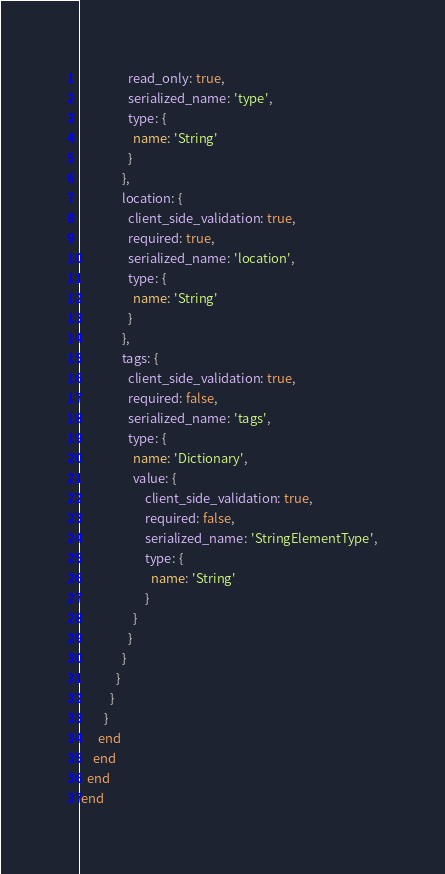Convert code to text. <code><loc_0><loc_0><loc_500><loc_500><_Ruby_>                read_only: true,
                serialized_name: 'type',
                type: {
                  name: 'String'
                }
              },
              location: {
                client_side_validation: true,
                required: true,
                serialized_name: 'location',
                type: {
                  name: 'String'
                }
              },
              tags: {
                client_side_validation: true,
                required: false,
                serialized_name: 'tags',
                type: {
                  name: 'Dictionary',
                  value: {
                      client_side_validation: true,
                      required: false,
                      serialized_name: 'StringElementType',
                      type: {
                        name: 'String'
                      }
                  }
                }
              }
            }
          }
        }
      end
    end
  end
end
</code> 